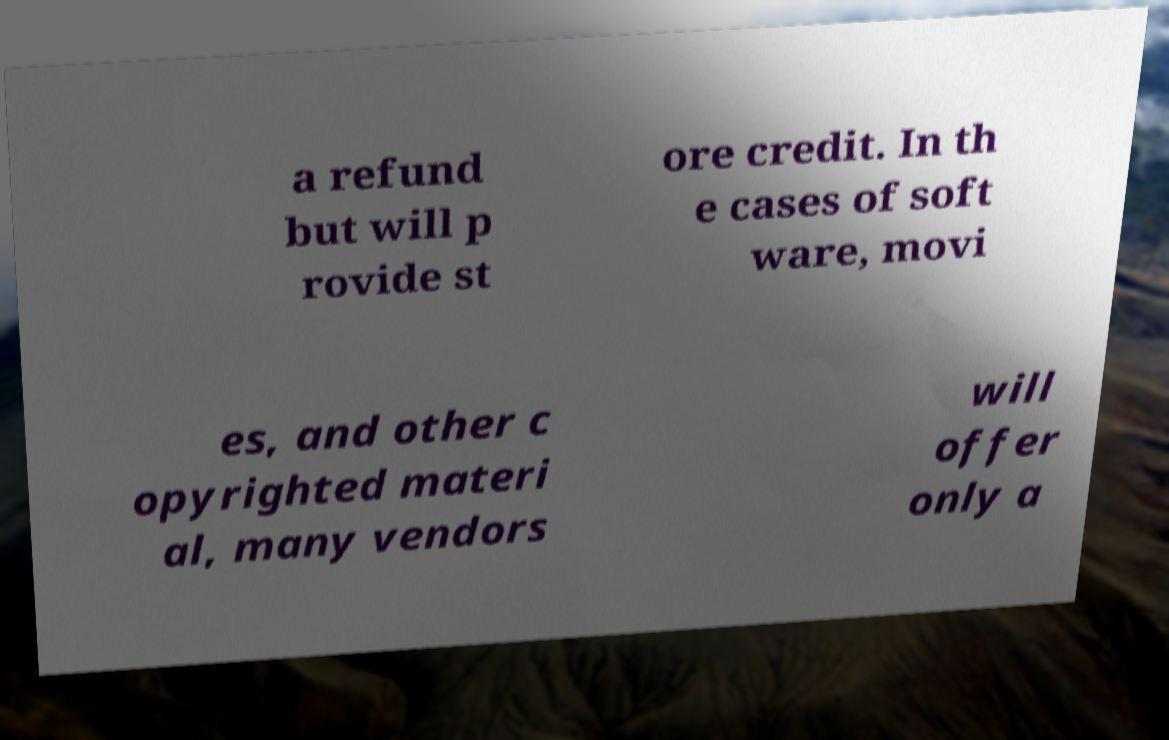Please read and relay the text visible in this image. What does it say? a refund but will p rovide st ore credit. In th e cases of soft ware, movi es, and other c opyrighted materi al, many vendors will offer only a 